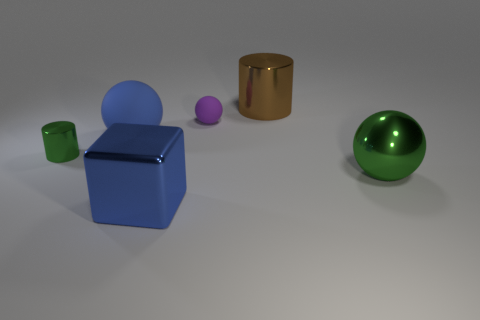Add 2 large blue rubber spheres. How many objects exist? 8 Subtract all cylinders. How many objects are left? 4 Add 6 small green cylinders. How many small green cylinders are left? 7 Add 6 large blue metal objects. How many large blue metal objects exist? 7 Subtract 0 red cubes. How many objects are left? 6 Subtract all big rubber cylinders. Subtract all tiny purple rubber spheres. How many objects are left? 5 